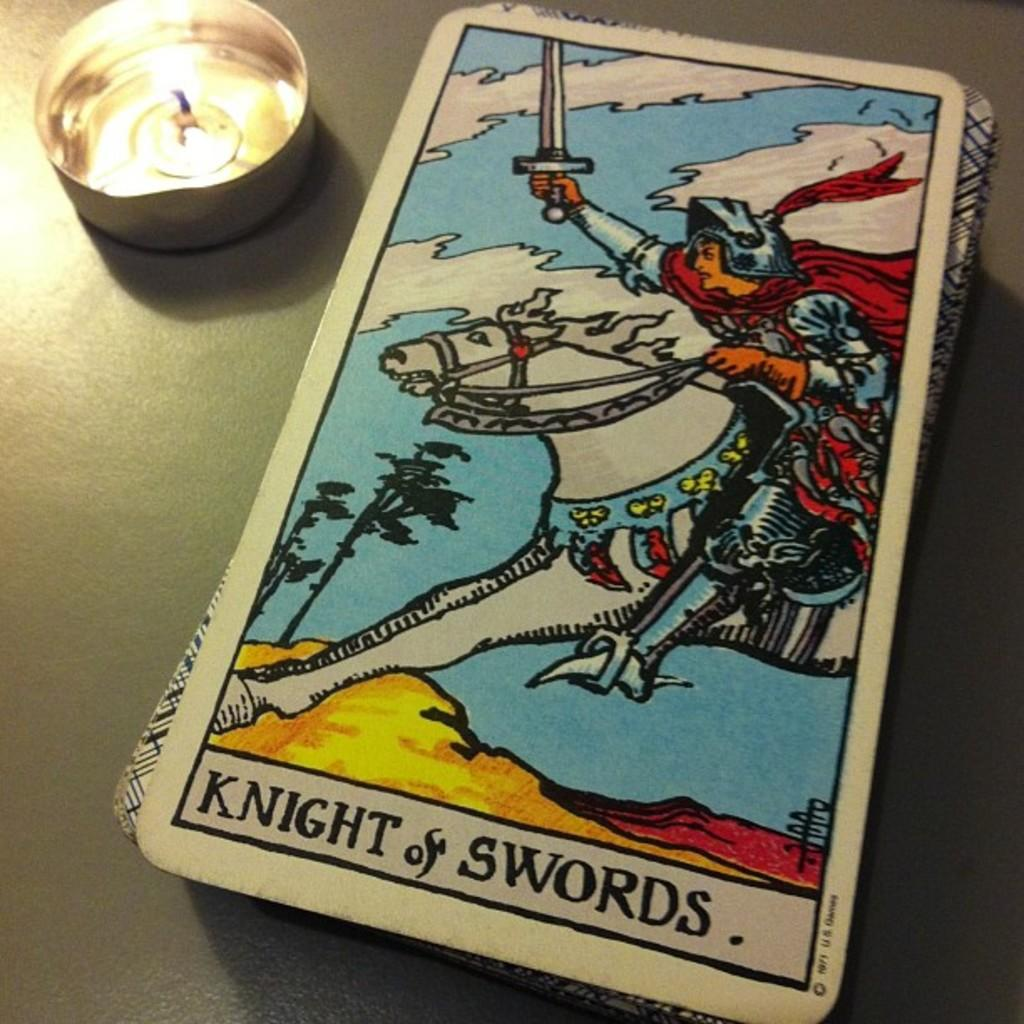What objects are present in the image? There are cards and a candle in the image. How are the cards arranged in the image? The cards are stacked one above the other on the right side of the image. What is the candle placed in? The candle is in a bowl. Where are the candle and bowl located in the image? The candle and bowl are on the left side of the image. What type of root can be seen growing from the cards in the image? There are no roots present in the image; the cards are stacked one above the other. 